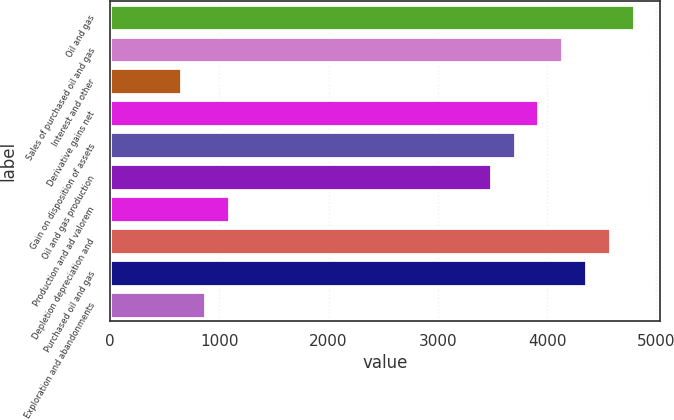<chart> <loc_0><loc_0><loc_500><loc_500><bar_chart><fcel>Oil and gas<fcel>Sales of purchased oil and gas<fcel>Interest and other<fcel>Derivative gains net<fcel>Gain on disposition of assets<fcel>Oil and gas production<fcel>Production and ad valorem<fcel>Depletion depreciation and<fcel>Purchased oil and gas<fcel>Exploration and abandonments<nl><fcel>4791.64<fcel>4138.24<fcel>653.44<fcel>3920.44<fcel>3702.64<fcel>3484.84<fcel>1089.04<fcel>4573.84<fcel>4356.04<fcel>871.24<nl></chart> 